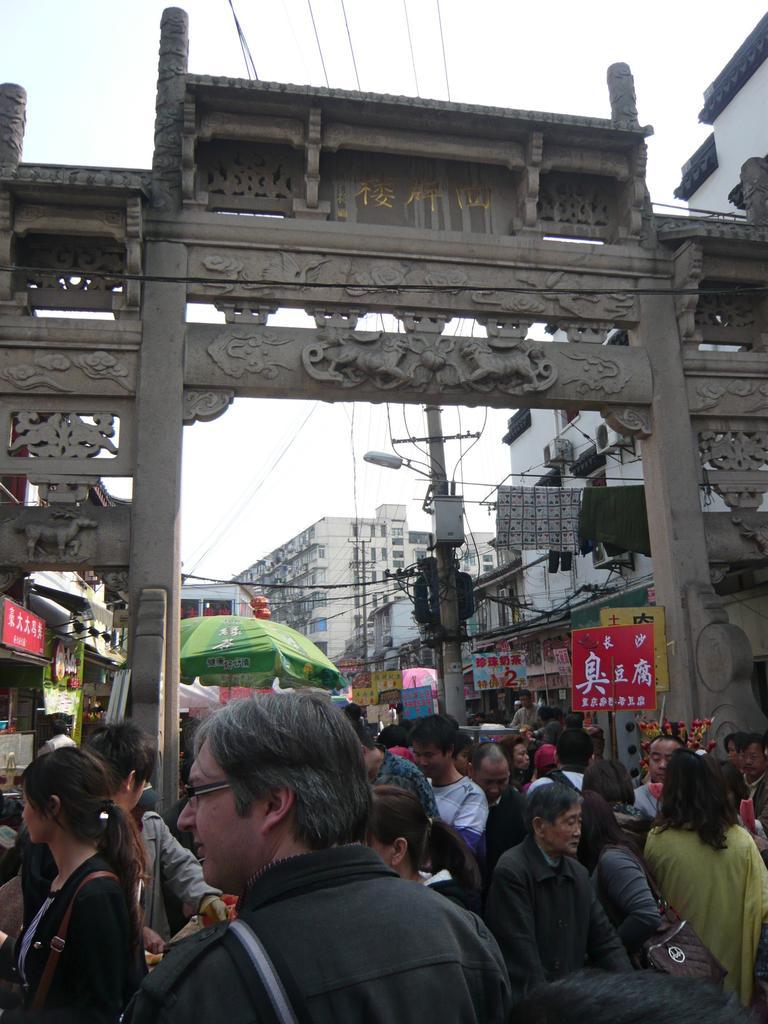Describe this image in one or two sentences. In this image there are few persons on the street. Bottom of the image there is a person wearing spectacles. Beside him there is a woman. There is an arch having few sculptures on it. Behind there is an umbrella. There is a pole having few wires attached to it. A lamp is attached to the pole. Few clothes are on the string which is attached to the pole. Background there are few buildings. Top of the image there is sky. 